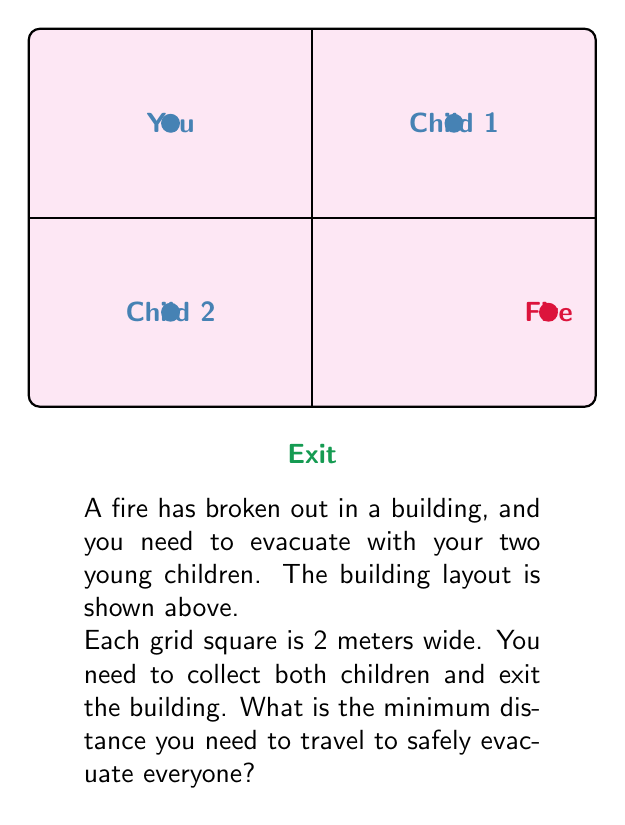Provide a solution to this math problem. Let's approach this step-by-step:

1) First, we need to calculate the distances:
   - From you to Child 1: $3 * 2 = 6$ meters
   - From Child 1 to Child 2: $3 * 2 + 2 * 2 = 10$ meters
   - From Child 2 to the exit: $1.5 * 2 = 3$ meters

2) The most efficient route would be:
   You → Child 1 → Child 2 → Exit

3) Let's calculate the total distance:
   $$ \text{Total Distance} = 6 + 10 + 3 = 19 \text{ meters} $$

4) It's important to note that this route avoids the fire and is the shortest path that collects both children before exiting.

5) Any other route would result in a longer distance or put you and the children at greater risk from the fire.
Answer: 19 meters 